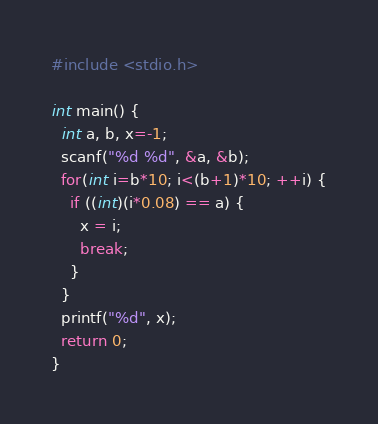Convert code to text. <code><loc_0><loc_0><loc_500><loc_500><_Python_>#include <stdio.h>

int main() {
  int a, b, x=-1;
  scanf("%d %d", &a, &b);
  for(int i=b*10; i<(b+1)*10; ++i) {
    if ((int)(i*0.08) == a) {
      x = i;
      break;
    }
  }
  printf("%d", x);
  return 0;
}
</code> 